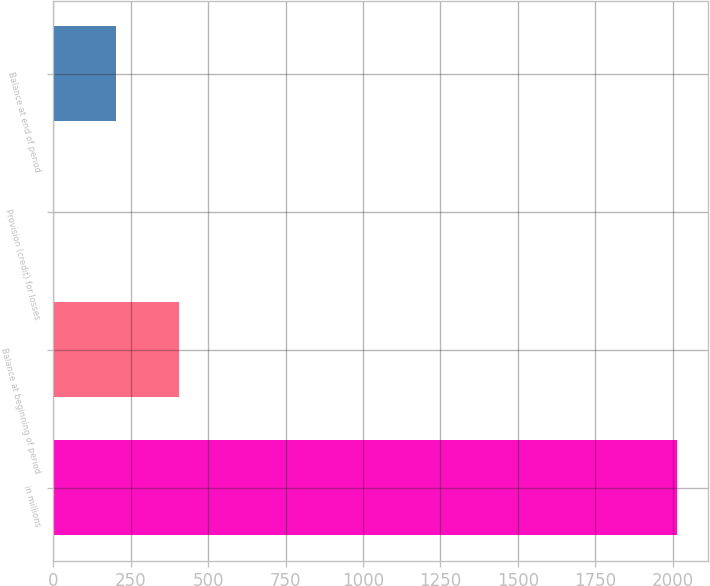Convert chart. <chart><loc_0><loc_0><loc_500><loc_500><bar_chart><fcel>in millions<fcel>Balance at beginning of period<fcel>Provision (credit) for losses<fcel>Balance at end of period<nl><fcel>2014<fcel>404.4<fcel>2<fcel>203.2<nl></chart> 